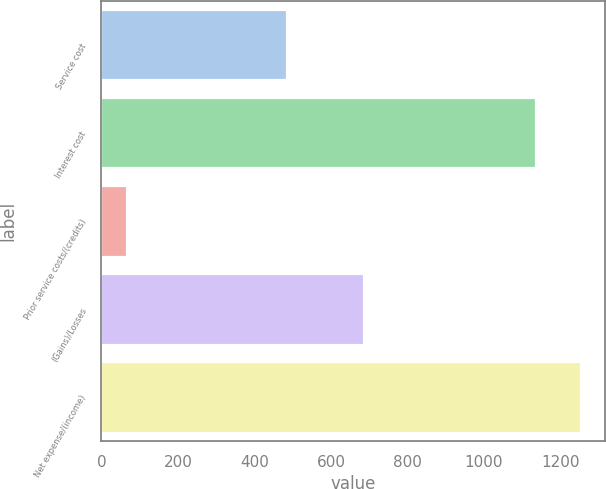<chart> <loc_0><loc_0><loc_500><loc_500><bar_chart><fcel>Service cost<fcel>Interest cost<fcel>Prior service costs/(credits)<fcel>(Gains)/Losses<fcel>Net expense/(income)<nl><fcel>484<fcel>1137<fcel>66<fcel>686<fcel>1254.2<nl></chart> 